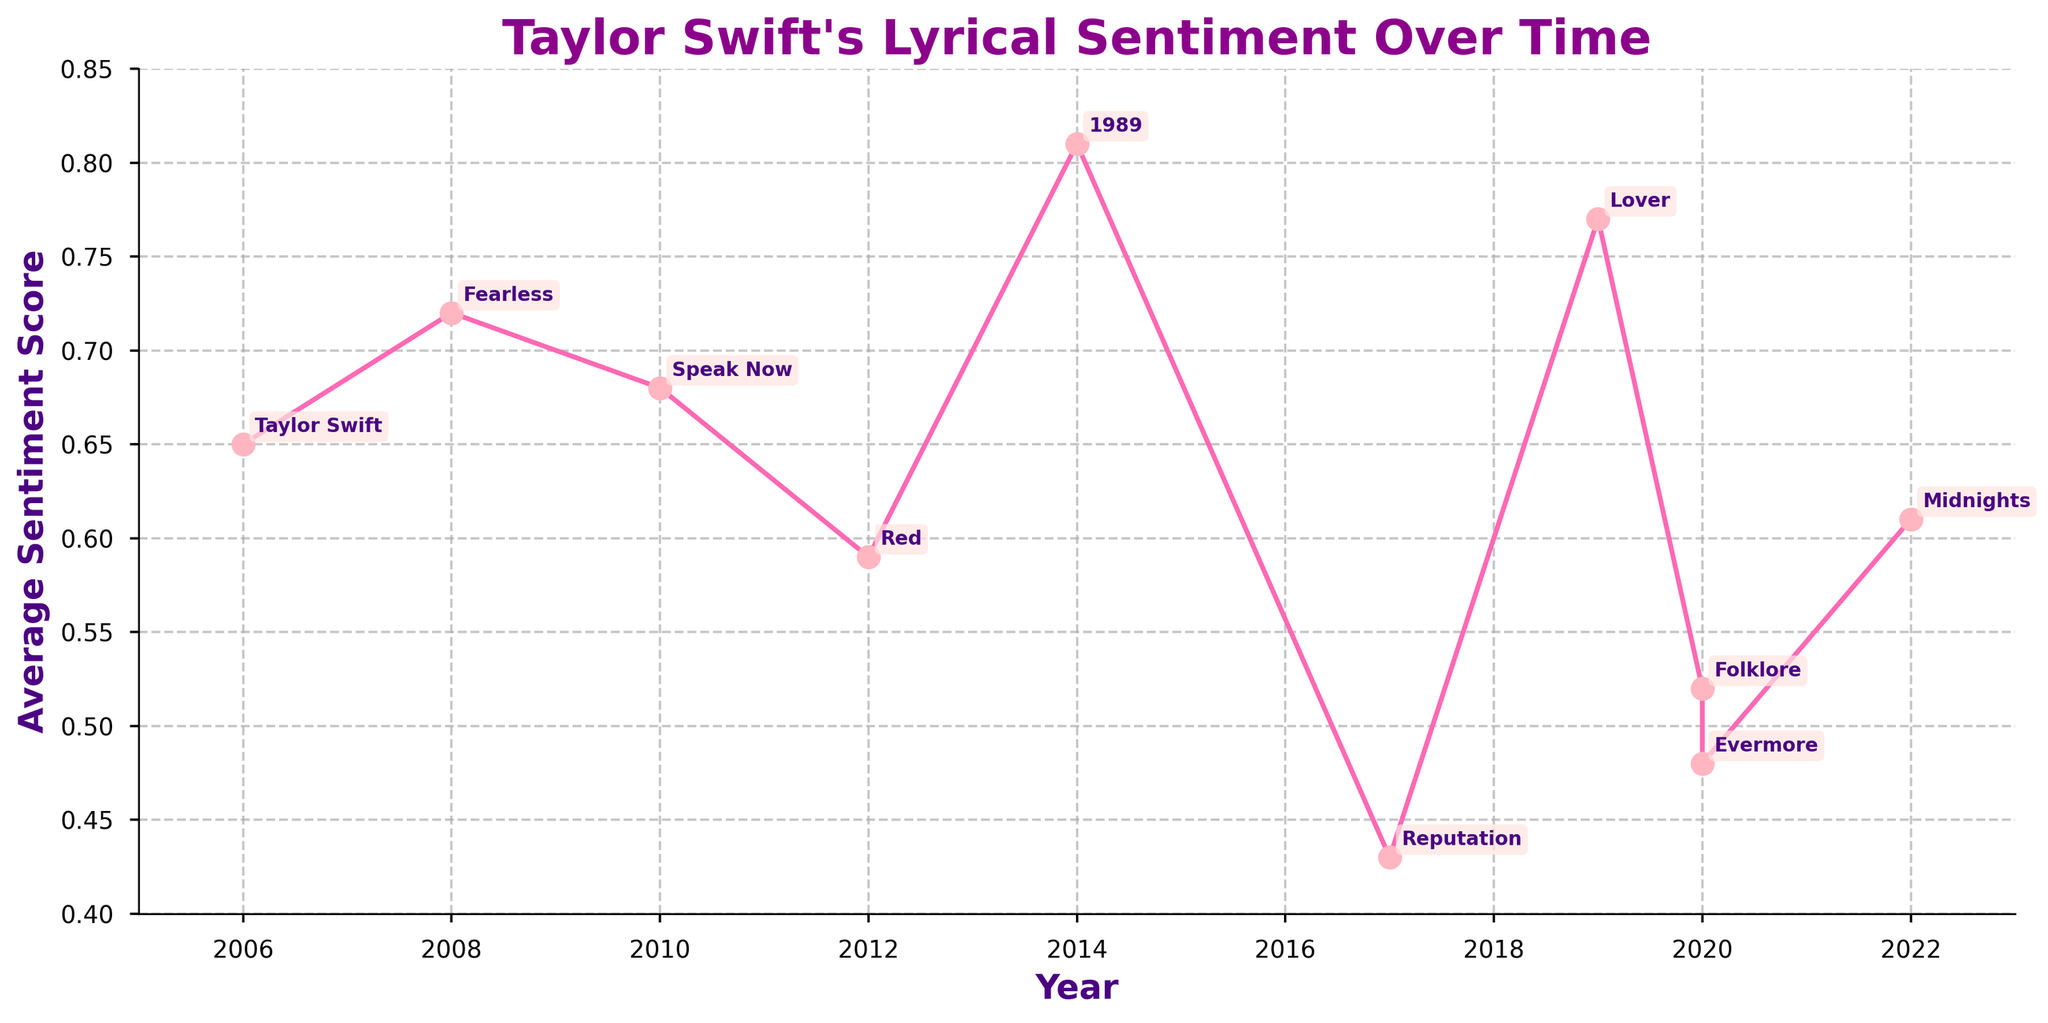What is the average sentiment score for the album with the lowest sentiment in Taylor Swift's discography? Identify the album with the lowest sentiment score by locating the lowest point on the graph. The lowest sentiment score belongs to "Reputation" in 2017.
Answer: 0.43 Between which two albums did the average sentiment score decline the most? Calculate the differences in average sentiment score between consecutive albums. The difference is the largest between "1989" (0.81) and "Reputation" (0.43), a decline of 0.38.
Answer: "1989" and "Reputation" Which album has the highest sentiment score and what year was it released? Locate the peak point on the graph. The highest sentiment is for the album "1989" released in 2014, visible as the highest point on the graph.
Answer: "1989" in 2014 How does the average sentiment score of 'Folklore' compare to 'Evermore'? Find the sentiment scores of both albums on the graph. 'Folklore' has a score of 0.52, and 'Evermore' has a score of 0.48. Comparing these values, 'Folklore' has a slightly higher sentiment score.
Answer: 'Folklore' is higher What is the difference in sentiment score between the albums "Red" and "Midnights"? Calculate the difference between the sentiment scores of "Red" (0.59) and "Midnights" (0.61). The difference is 0.61 - 0.59 = 0.02.
Answer: 0.02 What trend can be observed in the average sentiment score from 2006 to 2008? Look at the graph from 2006 to 2008. The sentiment score increases from 0.65 in 2006 ("Taylor Swift") to 0.72 in 2008 ("Fearless").
Answer: Increasing trend What is the median sentiment score across all the albums? List all sentiment scores: 0.65, 0.72, 0.68, 0.59, 0.81, 0.43, 0.77, 0.52, 0.48, and 0.61. Arrange them in ascending order: 0.43, 0.48, 0.52, 0.59, 0.61, 0.65, 0.68, 0.72, 0.77, 0.81. The median, being the middle value, is the average of the 5th and 6th values: (0.61 + 0.65) / 2 = 0.63.
Answer: 0.63 Which album released in 2020 had a higher sentiment score? "Folklore" and "Evermore" were both released in 2020. "Folklore" has a sentiment score of 0.52 while "Evermore" has a score of 0.48.
Answer: "Folklore" During which years did the highest change in sentiment score (increase or decrease) occur, and what was the change? Calculate differences between consecutive years. The largest change is between 2014 ("1989", 0.81) and 2017 ("Reputation", 0.43) which is a decrease by 0.38.
Answer: 2014 to 2017, a decrease of 0.38 